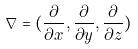<formula> <loc_0><loc_0><loc_500><loc_500>\nabla = ( \frac { \partial } { \partial x } , \frac { \partial } { \partial y } , \frac { \partial } { \partial z } )</formula> 